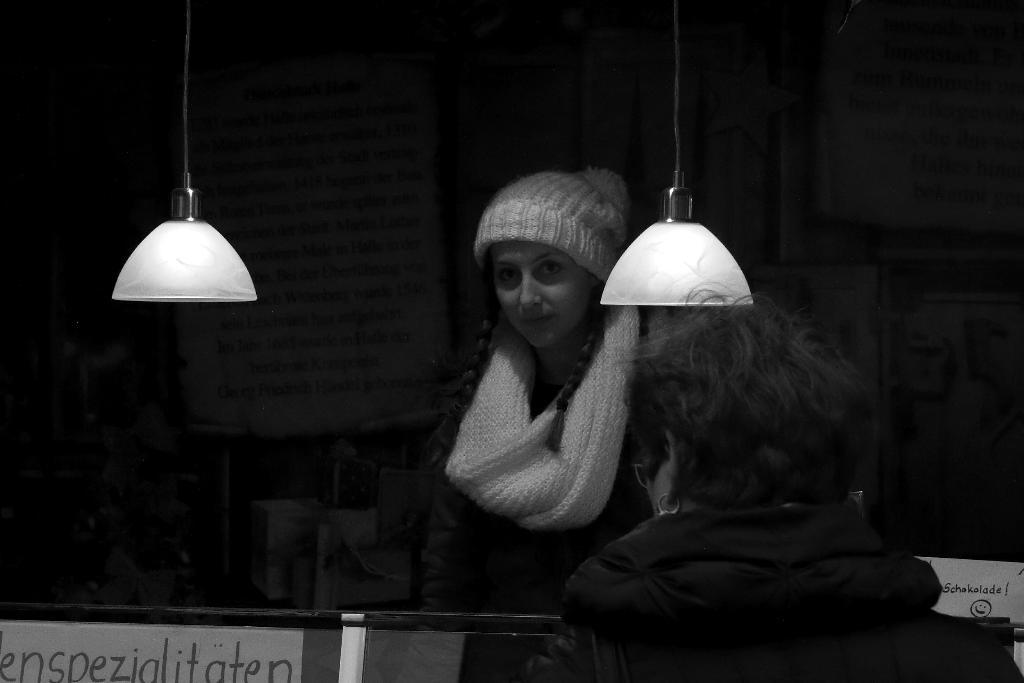How many people are present in the image? There are two persons in the image. What can be seen in the image besides the people? There are two lights and a board in the background of the image. What is written on the board? There is handwritten text on the board. What is the color scheme of the image? The image is black and white. What type of reward is being given to the person in the image? There is no reward being given in the image; it only features two persons, two lights, a board with handwritten text, and the image is black and white. 